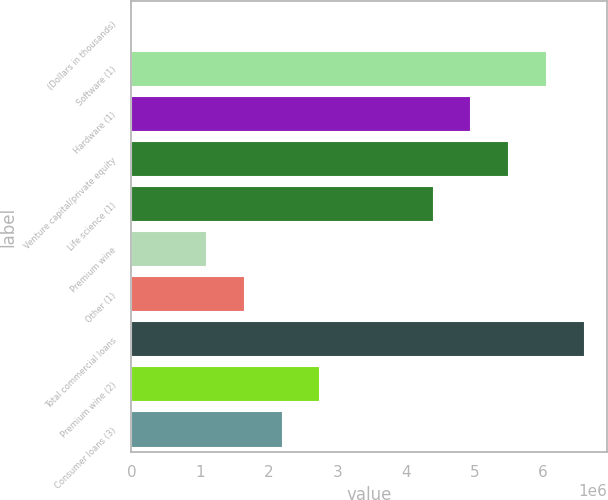<chart> <loc_0><loc_0><loc_500><loc_500><bar_chart><fcel>(Dollars in thousands)<fcel>Software (1)<fcel>Hardware (1)<fcel>Venture capital/private equity<fcel>Life science (1)<fcel>Premium wine<fcel>Other (1)<fcel>Total commercial loans<fcel>Premium wine (2)<fcel>Consumer loans (3)<nl><fcel>2008<fcel>6.05668e+06<fcel>4.95583e+06<fcel>5.50625e+06<fcel>4.4054e+06<fcel>1.10286e+06<fcel>1.65328e+06<fcel>6.6071e+06<fcel>2.75413e+06<fcel>2.20371e+06<nl></chart> 